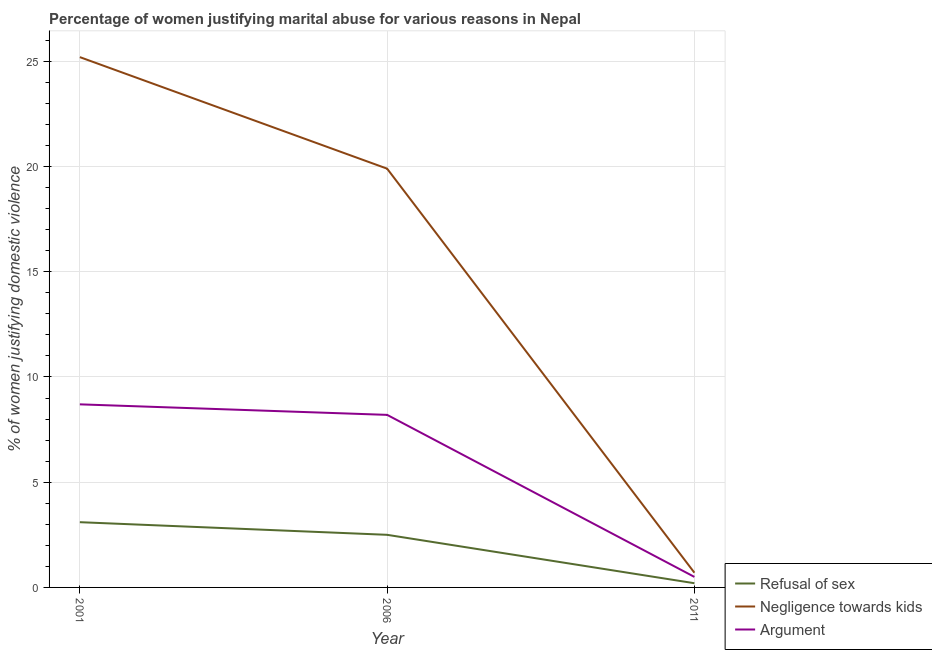How many different coloured lines are there?
Keep it short and to the point. 3. Is the number of lines equal to the number of legend labels?
Offer a very short reply. Yes. Across all years, what is the minimum percentage of women justifying domestic violence due to refusal of sex?
Provide a short and direct response. 0.2. In which year was the percentage of women justifying domestic violence due to refusal of sex minimum?
Offer a terse response. 2011. What is the total percentage of women justifying domestic violence due to arguments in the graph?
Ensure brevity in your answer.  17.4. What is the difference between the percentage of women justifying domestic violence due to refusal of sex in 2001 and that in 2006?
Keep it short and to the point. 0.6. What is the difference between the percentage of women justifying domestic violence due to negligence towards kids in 2006 and the percentage of women justifying domestic violence due to refusal of sex in 2001?
Give a very brief answer. 16.8. What is the average percentage of women justifying domestic violence due to refusal of sex per year?
Offer a terse response. 1.93. In the year 2006, what is the difference between the percentage of women justifying domestic violence due to arguments and percentage of women justifying domestic violence due to refusal of sex?
Provide a short and direct response. 5.7. In how many years, is the percentage of women justifying domestic violence due to negligence towards kids greater than 7 %?
Make the answer very short. 2. Is the percentage of women justifying domestic violence due to arguments in 2001 less than that in 2006?
Ensure brevity in your answer.  No. Is the difference between the percentage of women justifying domestic violence due to refusal of sex in 2001 and 2011 greater than the difference between the percentage of women justifying domestic violence due to negligence towards kids in 2001 and 2011?
Provide a succinct answer. No. What is the difference between the highest and the second highest percentage of women justifying domestic violence due to negligence towards kids?
Offer a terse response. 5.3. What is the difference between the highest and the lowest percentage of women justifying domestic violence due to negligence towards kids?
Give a very brief answer. 24.5. In how many years, is the percentage of women justifying domestic violence due to refusal of sex greater than the average percentage of women justifying domestic violence due to refusal of sex taken over all years?
Give a very brief answer. 2. Is the sum of the percentage of women justifying domestic violence due to negligence towards kids in 2006 and 2011 greater than the maximum percentage of women justifying domestic violence due to refusal of sex across all years?
Ensure brevity in your answer.  Yes. Does the percentage of women justifying domestic violence due to arguments monotonically increase over the years?
Your answer should be very brief. No. Is the percentage of women justifying domestic violence due to arguments strictly less than the percentage of women justifying domestic violence due to negligence towards kids over the years?
Give a very brief answer. Yes. How many years are there in the graph?
Offer a very short reply. 3. Does the graph contain any zero values?
Give a very brief answer. No. Where does the legend appear in the graph?
Offer a very short reply. Bottom right. What is the title of the graph?
Ensure brevity in your answer.  Percentage of women justifying marital abuse for various reasons in Nepal. Does "Ages 65 and above" appear as one of the legend labels in the graph?
Provide a short and direct response. No. What is the label or title of the X-axis?
Your answer should be very brief. Year. What is the label or title of the Y-axis?
Provide a succinct answer. % of women justifying domestic violence. What is the % of women justifying domestic violence in Negligence towards kids in 2001?
Your answer should be compact. 25.2. What is the % of women justifying domestic violence of Argument in 2001?
Your answer should be very brief. 8.7. What is the % of women justifying domestic violence in Argument in 2011?
Offer a terse response. 0.5. Across all years, what is the maximum % of women justifying domestic violence in Negligence towards kids?
Your answer should be compact. 25.2. Across all years, what is the minimum % of women justifying domestic violence of Refusal of sex?
Provide a succinct answer. 0.2. Across all years, what is the minimum % of women justifying domestic violence of Argument?
Provide a succinct answer. 0.5. What is the total % of women justifying domestic violence of Negligence towards kids in the graph?
Give a very brief answer. 45.8. What is the difference between the % of women justifying domestic violence in Refusal of sex in 2001 and that in 2006?
Your response must be concise. 0.6. What is the difference between the % of women justifying domestic violence of Negligence towards kids in 2001 and that in 2006?
Provide a succinct answer. 5.3. What is the difference between the % of women justifying domestic violence of Argument in 2001 and that in 2006?
Keep it short and to the point. 0.5. What is the difference between the % of women justifying domestic violence of Refusal of sex in 2001 and that in 2011?
Your answer should be very brief. 2.9. What is the difference between the % of women justifying domestic violence in Argument in 2001 and that in 2011?
Your answer should be compact. 8.2. What is the difference between the % of women justifying domestic violence of Refusal of sex in 2006 and that in 2011?
Ensure brevity in your answer.  2.3. What is the difference between the % of women justifying domestic violence of Negligence towards kids in 2006 and that in 2011?
Keep it short and to the point. 19.2. What is the difference between the % of women justifying domestic violence in Refusal of sex in 2001 and the % of women justifying domestic violence in Negligence towards kids in 2006?
Your response must be concise. -16.8. What is the difference between the % of women justifying domestic violence in Refusal of sex in 2001 and the % of women justifying domestic violence in Argument in 2006?
Your answer should be compact. -5.1. What is the difference between the % of women justifying domestic violence of Negligence towards kids in 2001 and the % of women justifying domestic violence of Argument in 2006?
Offer a very short reply. 17. What is the difference between the % of women justifying domestic violence in Refusal of sex in 2001 and the % of women justifying domestic violence in Negligence towards kids in 2011?
Make the answer very short. 2.4. What is the difference between the % of women justifying domestic violence in Refusal of sex in 2001 and the % of women justifying domestic violence in Argument in 2011?
Provide a short and direct response. 2.6. What is the difference between the % of women justifying domestic violence in Negligence towards kids in 2001 and the % of women justifying domestic violence in Argument in 2011?
Ensure brevity in your answer.  24.7. What is the average % of women justifying domestic violence of Refusal of sex per year?
Ensure brevity in your answer.  1.93. What is the average % of women justifying domestic violence in Negligence towards kids per year?
Your answer should be compact. 15.27. In the year 2001, what is the difference between the % of women justifying domestic violence in Refusal of sex and % of women justifying domestic violence in Negligence towards kids?
Give a very brief answer. -22.1. In the year 2006, what is the difference between the % of women justifying domestic violence of Refusal of sex and % of women justifying domestic violence of Negligence towards kids?
Keep it short and to the point. -17.4. In the year 2006, what is the difference between the % of women justifying domestic violence of Refusal of sex and % of women justifying domestic violence of Argument?
Provide a succinct answer. -5.7. In the year 2006, what is the difference between the % of women justifying domestic violence in Negligence towards kids and % of women justifying domestic violence in Argument?
Keep it short and to the point. 11.7. In the year 2011, what is the difference between the % of women justifying domestic violence in Refusal of sex and % of women justifying domestic violence in Argument?
Keep it short and to the point. -0.3. In the year 2011, what is the difference between the % of women justifying domestic violence in Negligence towards kids and % of women justifying domestic violence in Argument?
Keep it short and to the point. 0.2. What is the ratio of the % of women justifying domestic violence of Refusal of sex in 2001 to that in 2006?
Ensure brevity in your answer.  1.24. What is the ratio of the % of women justifying domestic violence in Negligence towards kids in 2001 to that in 2006?
Ensure brevity in your answer.  1.27. What is the ratio of the % of women justifying domestic violence of Argument in 2001 to that in 2006?
Offer a terse response. 1.06. What is the ratio of the % of women justifying domestic violence of Refusal of sex in 2006 to that in 2011?
Ensure brevity in your answer.  12.5. What is the ratio of the % of women justifying domestic violence in Negligence towards kids in 2006 to that in 2011?
Offer a very short reply. 28.43. What is the difference between the highest and the lowest % of women justifying domestic violence in Refusal of sex?
Your answer should be compact. 2.9. What is the difference between the highest and the lowest % of women justifying domestic violence of Negligence towards kids?
Offer a very short reply. 24.5. 